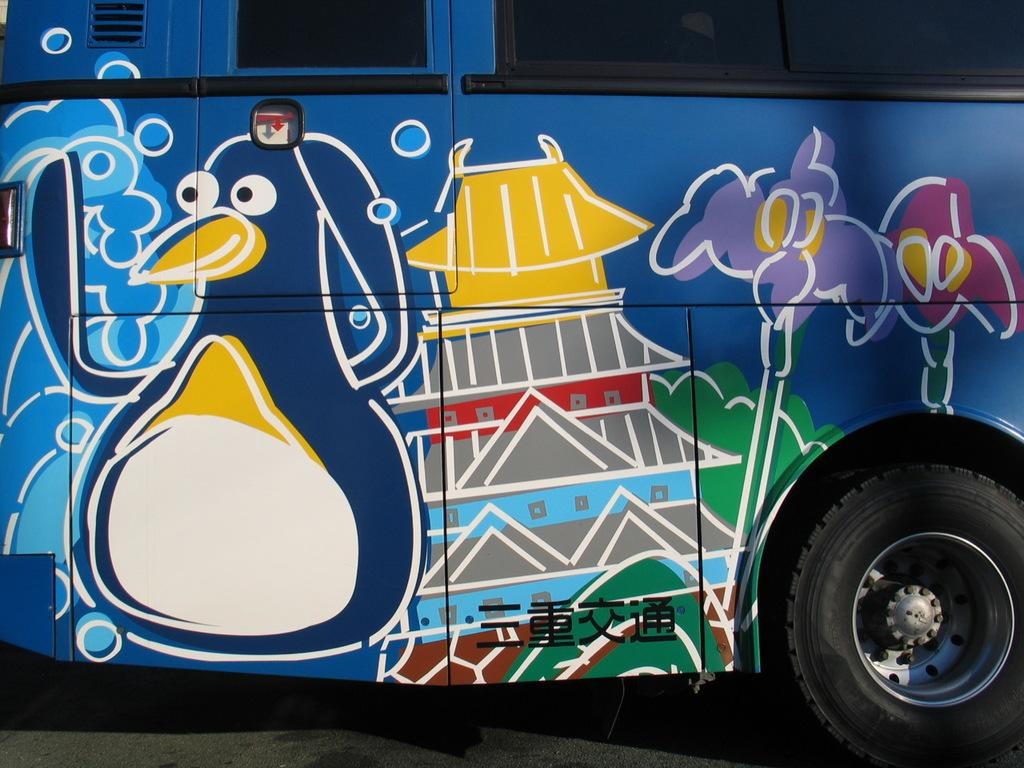What is the main subject of the image? The main subject of the image is a bus. Where is the bus located in the image? The bus is on the road in the image. What type of family can be seen arguing near the bus in the image? There is no family or argument present in the image; it only features a bus on the road. 